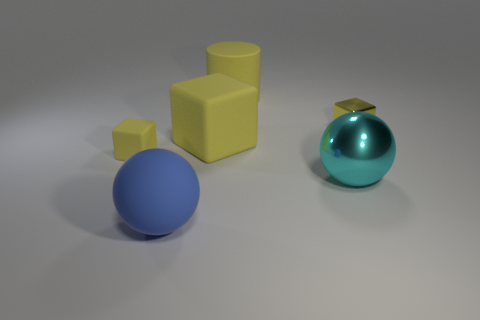Is the number of big cyan metallic spheres that are in front of the big blue rubber thing greater than the number of large purple matte cylinders?
Provide a short and direct response. No. How many blocks are either yellow rubber objects or large purple metal objects?
Provide a short and direct response. 2. The large matte object that is in front of the big yellow cylinder and behind the blue rubber ball has what shape?
Provide a succinct answer. Cube. Are there an equal number of things behind the blue rubber thing and cubes that are to the left of the metallic cube?
Provide a succinct answer. No. How many objects are large matte cylinders or blue objects?
Offer a very short reply. 2. The rubber block that is the same size as the cyan shiny thing is what color?
Your answer should be compact. Yellow. What number of things are yellow cubes to the left of the large cyan metallic object or rubber things that are behind the big blue thing?
Keep it short and to the point. 3. Are there an equal number of small rubber objects that are in front of the tiny yellow rubber object and small yellow metallic things?
Keep it short and to the point. No. There is a sphere on the left side of the yellow cylinder; does it have the same size as the metal thing that is behind the cyan shiny sphere?
Ensure brevity in your answer.  No. How many other things are the same size as the blue matte sphere?
Give a very brief answer. 3. 